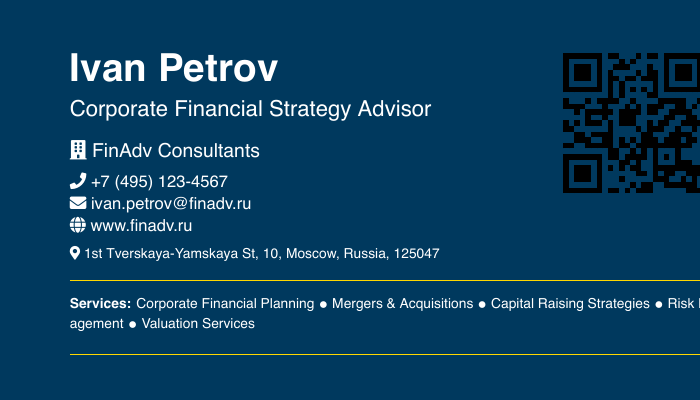What is the advisor's name? The advisor's name is prominently displayed at the top of the document.
Answer: Ivan Petrov What title does Ivan Petrov hold? The title is specified under the name in a larger font size.
Answer: Corporate Financial Strategy Advisor Which company does Ivan Petrov work for? The company name is listed below the title.
Answer: FinAdv Consultants What is the phone number listed on the business card? The phone number is presented next to a phone icon.
Answer: +7 (495) 123-4567 What services does Ivan Petrov provide? The services are listed in a specific section of the document.
Answer: Corporate Financial Planning How many services are listed on the business card? The services are separated by bullet points, indicating the number of distinct services.
Answer: Five What is the email address for Ivan Petrov? The email address appears below the phone number.
Answer: ivan.petrov@finadv.ru What is the address of FinAdv Consultants? The address is detailed towards the bottom of the card.
Answer: 1st Tverskaya-Yamskaya St, 10, Moscow, Russia, 125047 What color is the background of the business card? The background color is described as part of the document's style settings.
Answer: Russian Blue What is the website URL provided on the card? The website is listed with a globe icon next to it.
Answer: www.finadv.ru 